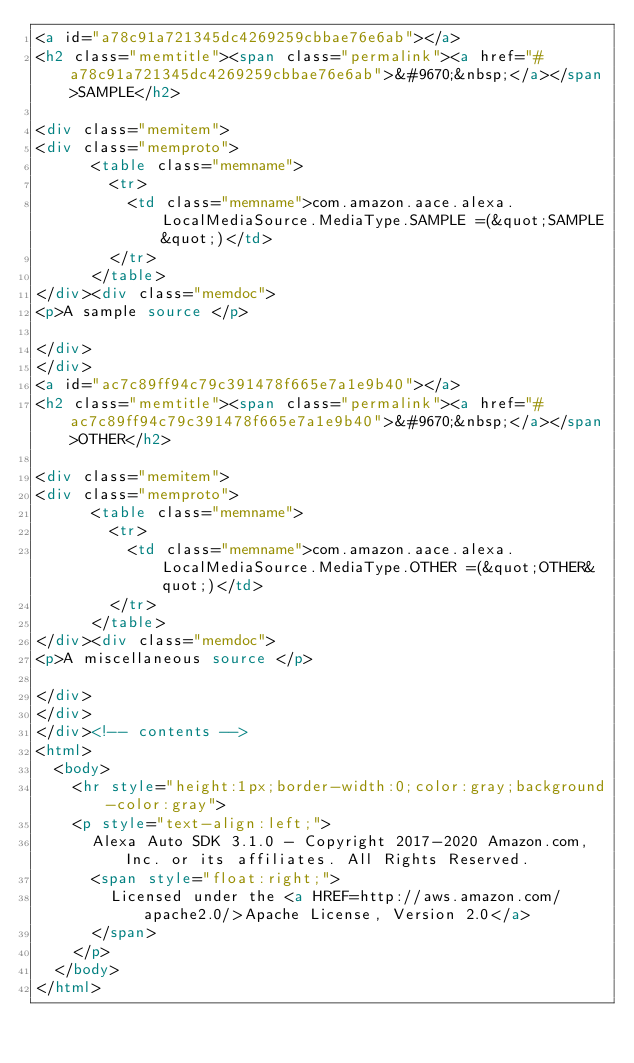Convert code to text. <code><loc_0><loc_0><loc_500><loc_500><_HTML_><a id="a78c91a721345dc4269259cbbae76e6ab"></a>
<h2 class="memtitle"><span class="permalink"><a href="#a78c91a721345dc4269259cbbae76e6ab">&#9670;&nbsp;</a></span>SAMPLE</h2>

<div class="memitem">
<div class="memproto">
      <table class="memname">
        <tr>
          <td class="memname">com.amazon.aace.alexa.LocalMediaSource.MediaType.SAMPLE =(&quot;SAMPLE&quot;)</td>
        </tr>
      </table>
</div><div class="memdoc">
<p>A sample source </p>

</div>
</div>
<a id="ac7c89ff94c79c391478f665e7a1e9b40"></a>
<h2 class="memtitle"><span class="permalink"><a href="#ac7c89ff94c79c391478f665e7a1e9b40">&#9670;&nbsp;</a></span>OTHER</h2>

<div class="memitem">
<div class="memproto">
      <table class="memname">
        <tr>
          <td class="memname">com.amazon.aace.alexa.LocalMediaSource.MediaType.OTHER =(&quot;OTHER&quot;)</td>
        </tr>
      </table>
</div><div class="memdoc">
<p>A miscellaneous source </p>

</div>
</div>
</div><!-- contents -->
<html>
  <body>
    <hr style="height:1px;border-width:0;color:gray;background-color:gray">
    <p style="text-align:left;">
      Alexa Auto SDK 3.1.0 - Copyright 2017-2020 Amazon.com, Inc. or its affiliates. All Rights Reserved.
      <span style="float:right;">
        Licensed under the <a HREF=http://aws.amazon.com/apache2.0/>Apache License, Version 2.0</a>
      </span>
    </p>
  </body>
</html>
</code> 